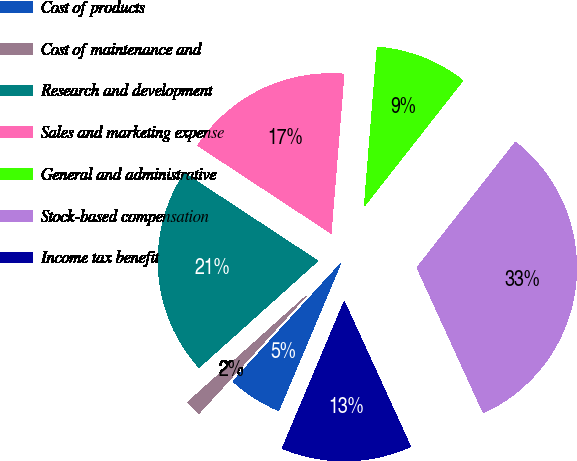<chart> <loc_0><loc_0><loc_500><loc_500><pie_chart><fcel>Cost of products<fcel>Cost of maintenance and<fcel>Research and development<fcel>Sales and marketing expense<fcel>General and administrative<fcel>Stock-based compensation<fcel>Income tax benefit<nl><fcel>5.44%<fcel>1.57%<fcel>20.9%<fcel>17.03%<fcel>9.3%<fcel>32.59%<fcel>13.17%<nl></chart> 